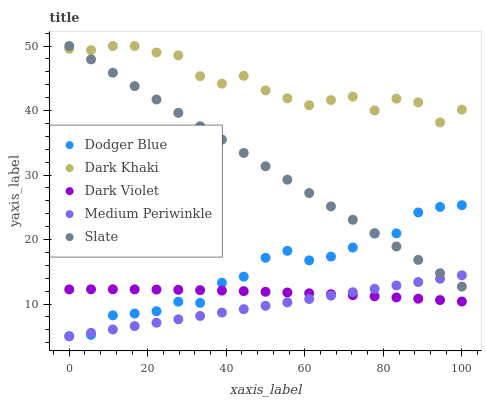Does Medium Periwinkle have the minimum area under the curve?
Answer yes or no. Yes. Does Dark Khaki have the maximum area under the curve?
Answer yes or no. Yes. Does Slate have the minimum area under the curve?
Answer yes or no. No. Does Slate have the maximum area under the curve?
Answer yes or no. No. Is Medium Periwinkle the smoothest?
Answer yes or no. Yes. Is Dark Khaki the roughest?
Answer yes or no. Yes. Is Slate the smoothest?
Answer yes or no. No. Is Slate the roughest?
Answer yes or no. No. Does Medium Periwinkle have the lowest value?
Answer yes or no. Yes. Does Slate have the lowest value?
Answer yes or no. No. Does Slate have the highest value?
Answer yes or no. Yes. Does Medium Periwinkle have the highest value?
Answer yes or no. No. Is Dodger Blue less than Dark Khaki?
Answer yes or no. Yes. Is Dark Khaki greater than Medium Periwinkle?
Answer yes or no. Yes. Does Dark Violet intersect Dodger Blue?
Answer yes or no. Yes. Is Dark Violet less than Dodger Blue?
Answer yes or no. No. Is Dark Violet greater than Dodger Blue?
Answer yes or no. No. Does Dodger Blue intersect Dark Khaki?
Answer yes or no. No. 